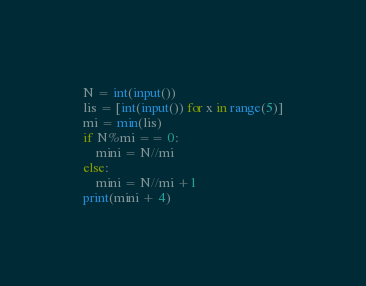Convert code to text. <code><loc_0><loc_0><loc_500><loc_500><_Python_>N = int(input())
lis = [int(input()) for x in range(5)]
mi = min(lis)
if N%mi == 0:
    mini = N//mi
else:
    mini = N//mi +1
print(mini + 4)</code> 